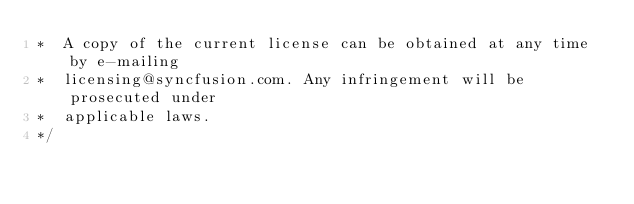<code> <loc_0><loc_0><loc_500><loc_500><_JavaScript_>*  A copy of the current license can be obtained at any time by e-mailing
*  licensing@syncfusion.com. Any infringement will be prosecuted under
*  applicable laws. 
*/</code> 